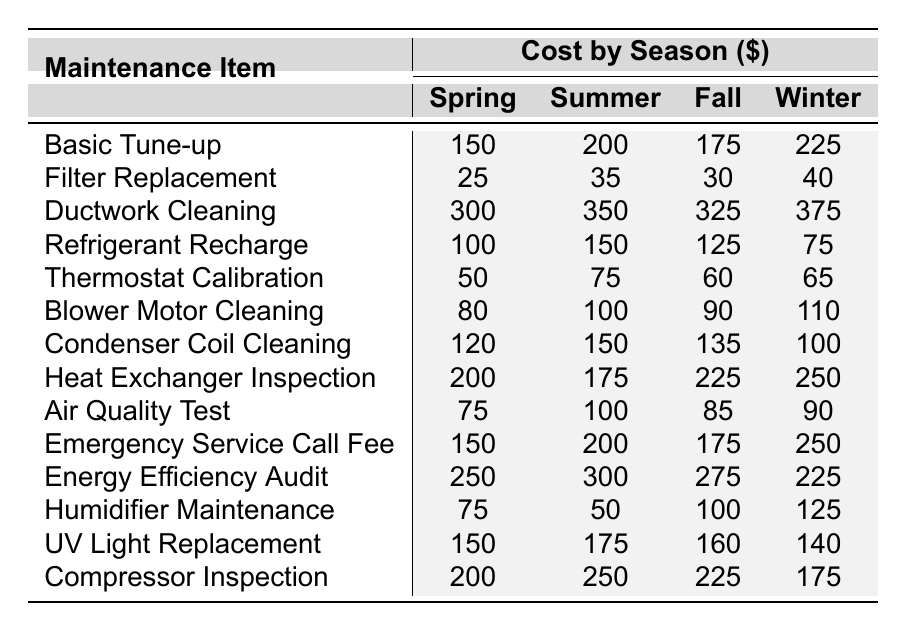What is the cost of Ductwork Cleaning in Summer? The table shows the cost of Ductwork Cleaning listed under the Summer column, which is $350.
Answer: 350 Which season has the highest cost for Basic Tune-up? By inspecting the Basic Tune-up costs for each season, we can see Winter at $225 is the highest.
Answer: Winter What is the total cost of Filter Replacement across all seasons? Adding the costs from all seasons: 25 (Spring) + 35 (Summer) + 30 (Fall) + 40 (Winter) gives a total of 130.
Answer: 130 Is the cost of Compressor Inspection in Fall greater than in Winter? The cost in Fall is $225 and in Winter is $175. Since 225 is greater than 175, the answer is yes.
Answer: Yes What season has the lowest average cost for HVAC maintenance? First, calculate the average for each season. Spring: 150 + 25 + 300 + 100 + 50 + 80 + 120 + 200 + 75 + 150 + 250 + 75 + 150 + 200 = 1883, divided by 14 gives approx. 134.5. Summer gives $198.5, Fall gives $196.4, and Winter gives $196.5. Spring has the lowest average maintenance cost.
Answer: Spring Which maintenance item is the most expensive in Winter? Looking at the Winter costs in the table, Ductwork Cleaning at $375 is the highest.
Answer: Ductwork Cleaning How much more does the Energy Efficiency Audit cost in Summer compared to Spring? The Summer cost is $300 and the Spring cost is $250. Subtracting these gives $50 more in Summer.
Answer: 50 Which maintenance item has the biggest cost difference between Spring and Summer? The largest difference is found by comparing costs: Ductwork Cleaning $350 - $300 = $50, and other items have lower discrepancies. Hence, Ductwork Cleaning has the biggest difference of $50.
Answer: Ductwork Cleaning Are the costs for Thermostat Calibration in Fall and Winter equal? The Fall cost is $60 and Winter is $65. Since they are not equal, the answer is no.
Answer: No What is the average cost of all maintenance items in Fall? Adding all Fall costs: 175 (Basic Tune-up) + 30 + 325 + 125 + 60 + 90 + 135 + 225 + 85 + 175 + 275 + 100 + 160 + 225 = 1845. With 14 items, the average is 1845/14 = 131.07.
Answer: 131.07 